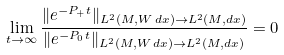Convert formula to latex. <formula><loc_0><loc_0><loc_500><loc_500>\lim _ { t \to \infty } \frac { \| e ^ { - P _ { + } t } \| _ { L ^ { 2 } ( M , W \, d x ) \to L ^ { 2 } ( M , d x ) } } { \| e ^ { - P _ { 0 } t } \| _ { L ^ { 2 } ( M , W \, d x ) \to L ^ { 2 } ( M , d x ) } } = 0</formula> 